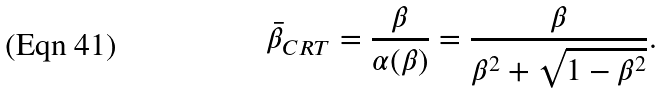Convert formula to latex. <formula><loc_0><loc_0><loc_500><loc_500>\bar { \beta } _ { C R T } = \frac { \beta } { \alpha ( \beta ) } = \frac { \beta } { \beta ^ { 2 } + \sqrt { 1 - \beta ^ { 2 } } } .</formula> 